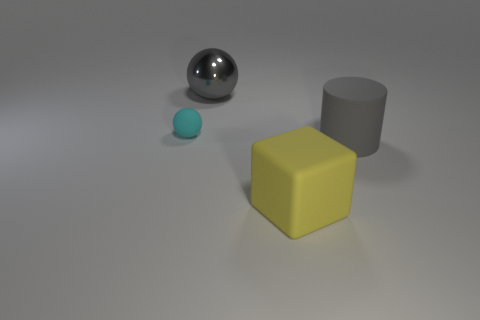Add 3 cyan balls. How many objects exist? 7 Subtract all cylinders. How many objects are left? 3 Subtract 0 blue spheres. How many objects are left? 4 Subtract all big cylinders. Subtract all gray metallic things. How many objects are left? 2 Add 4 small rubber things. How many small rubber things are left? 5 Add 2 gray cylinders. How many gray cylinders exist? 3 